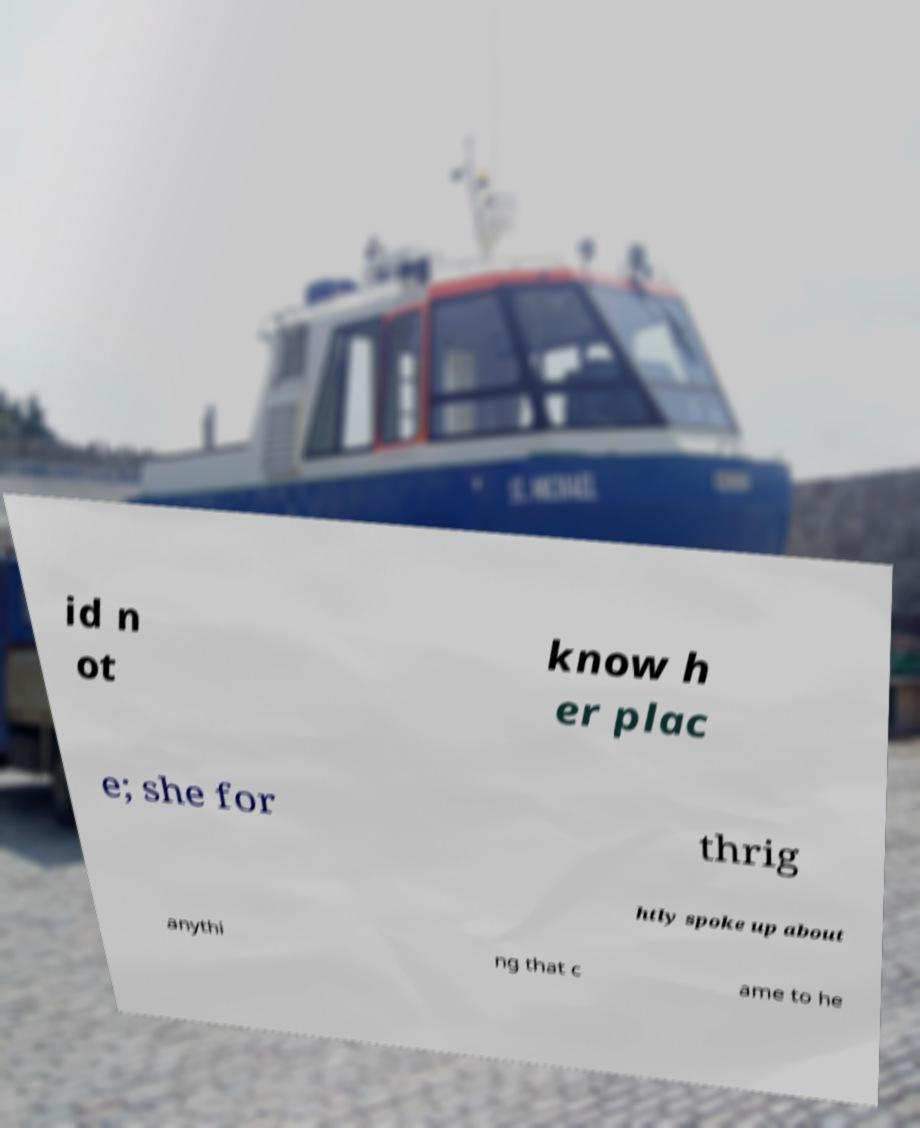I need the written content from this picture converted into text. Can you do that? id n ot know h er plac e; she for thrig htly spoke up about anythi ng that c ame to he 